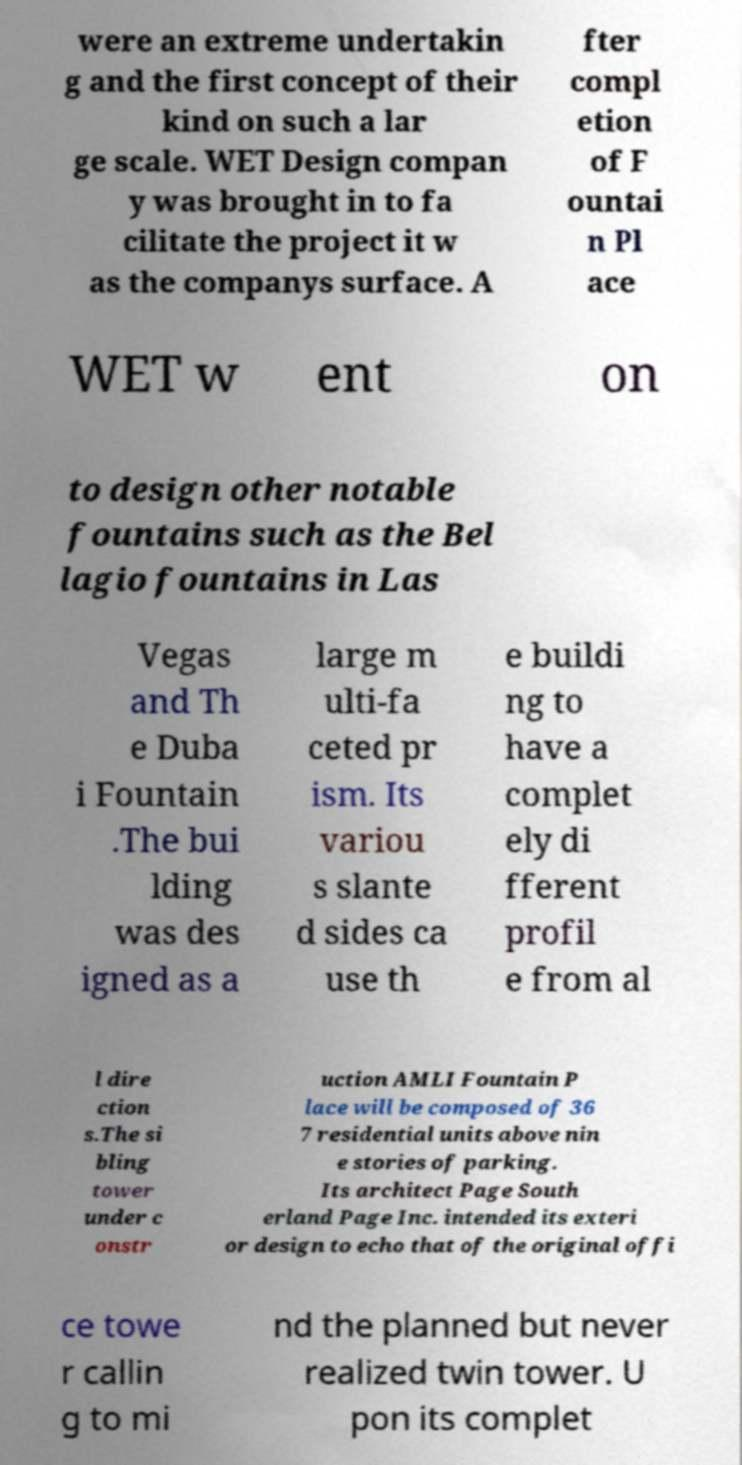There's text embedded in this image that I need extracted. Can you transcribe it verbatim? were an extreme undertakin g and the first concept of their kind on such a lar ge scale. WET Design compan y was brought in to fa cilitate the project it w as the companys surface. A fter compl etion of F ountai n Pl ace WET w ent on to design other notable fountains such as the Bel lagio fountains in Las Vegas and Th e Duba i Fountain .The bui lding was des igned as a large m ulti-fa ceted pr ism. Its variou s slante d sides ca use th e buildi ng to have a complet ely di fferent profil e from al l dire ction s.The si bling tower under c onstr uction AMLI Fountain P lace will be composed of 36 7 residential units above nin e stories of parking. Its architect Page South erland Page Inc. intended its exteri or design to echo that of the original offi ce towe r callin g to mi nd the planned but never realized twin tower. U pon its complet 